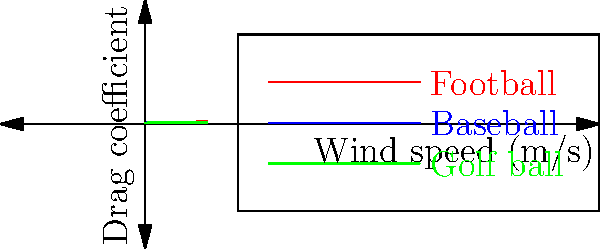Based on the wind tunnel diagram showing the drag coefficient versus wind speed for different sports balls, which ball exhibits the highest drag coefficient at low wind speeds but experiences the most significant reduction in drag as wind speed increases? To answer this question, we need to analyze the graph for each sports ball:

1. Football (red line):
   - Starts with the highest drag coefficient at low wind speeds.
   - Shows a significant decrease in drag coefficient as wind speed increases.
   - The curve has the steepest initial slope.

2. Baseball (blue line):
   - Starts with a moderate drag coefficient at low wind speeds.
   - Shows a moderate decrease in drag coefficient as wind speed increases.
   - The curve has a less steep slope compared to the football.

3. Golf ball (green line):
   - Starts with the lowest drag coefficient at low wind speeds.
   - Shows the least decrease in drag coefficient as wind speed increases.
   - The curve has the gentlest slope.

Comparing these three curves:
- The football has the highest starting point, indicating the highest drag coefficient at low wind speeds.
- The football's curve also shows the most dramatic decrease (steepest slope) as wind speed increases.

This behavior can be attributed to the football's shape and surface characteristics. At low speeds, its larger surface area and irregular shape contribute to higher drag. As speed increases, the ball's orientation and the air flow around it become more streamlined, leading to a more significant reduction in drag compared to the other balls.
Answer: Football 